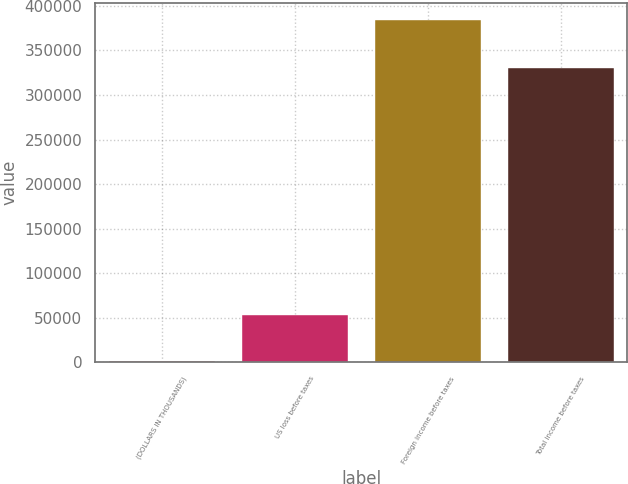Convert chart. <chart><loc_0><loc_0><loc_500><loc_500><bar_chart><fcel>(DOLLARS IN THOUSANDS)<fcel>US loss before taxes<fcel>Foreign income before taxes<fcel>Total income before taxes<nl><fcel>2007<fcel>53159<fcel>383973<fcel>330814<nl></chart> 